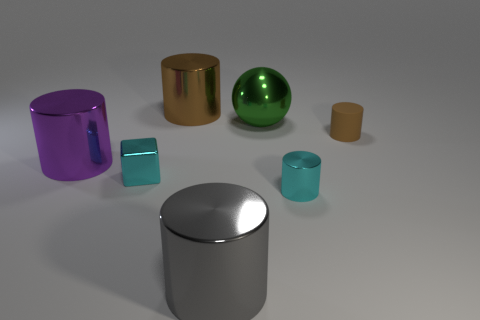How many objects are either metal objects that are on the left side of the big green shiny thing or large shiny cylinders behind the cyan shiny cube?
Ensure brevity in your answer.  4. There is a rubber cylinder; is its color the same as the big metal object that is to the left of the small cube?
Offer a very short reply. No. The brown object that is the same material as the green ball is what shape?
Offer a very short reply. Cylinder. How many red shiny objects are there?
Ensure brevity in your answer.  0. How many objects are tiny cyan objects left of the ball or metal things?
Provide a succinct answer. 6. There is a small metal object right of the small metal cube; does it have the same color as the tiny matte object?
Offer a terse response. No. How many other objects are the same color as the rubber cylinder?
Give a very brief answer. 1. How many small things are either cyan shiny cylinders or gray metal objects?
Your response must be concise. 1. Is the number of small brown cylinders greater than the number of red objects?
Your response must be concise. Yes. Do the big green thing and the gray cylinder have the same material?
Your answer should be very brief. Yes. 